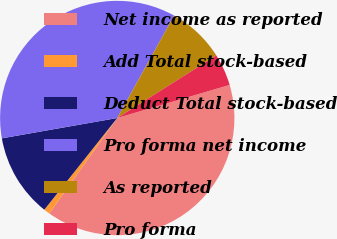Convert chart to OTSL. <chart><loc_0><loc_0><loc_500><loc_500><pie_chart><fcel>Net income as reported<fcel>Add Total stock-based<fcel>Deduct Total stock-based<fcel>Pro forma net income<fcel>As reported<fcel>Pro forma<nl><fcel>39.41%<fcel>0.84%<fcel>11.53%<fcel>35.84%<fcel>7.97%<fcel>4.41%<nl></chart> 